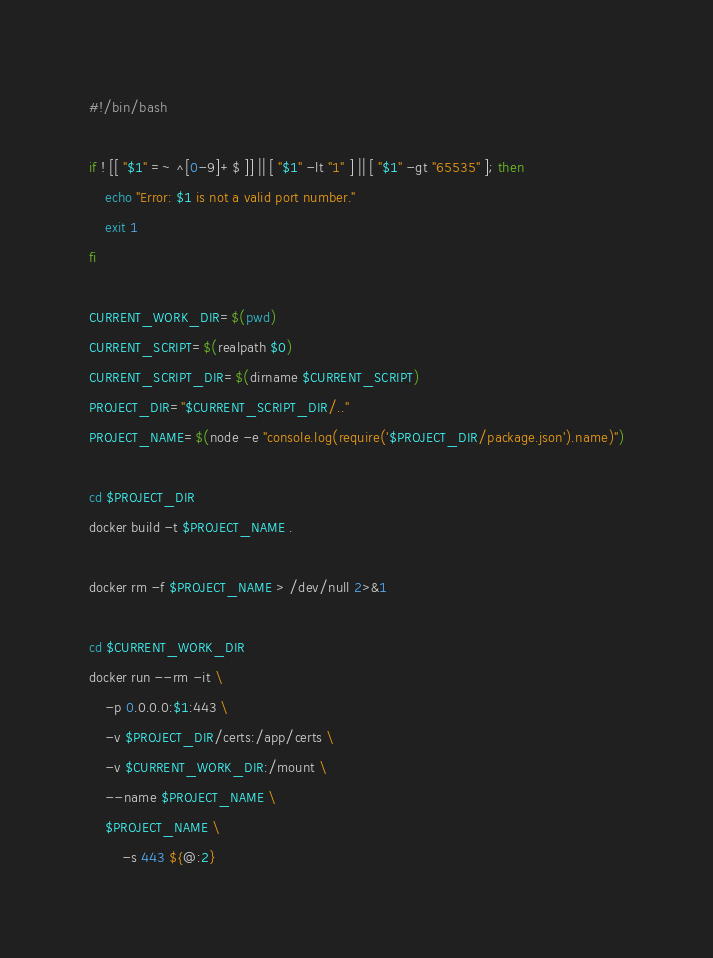Convert code to text. <code><loc_0><loc_0><loc_500><loc_500><_Bash_>#!/bin/bash

if ! [[ "$1" =~ ^[0-9]+$ ]] || [ "$1" -lt "1" ] || [ "$1" -gt "65535" ]; then
    echo "Error: $1 is not a valid port number."
    exit 1
fi

CURRENT_WORK_DIR=$(pwd)
CURRENT_SCRIPT=$(realpath $0)
CURRENT_SCRIPT_DIR=$(dirname $CURRENT_SCRIPT)
PROJECT_DIR="$CURRENT_SCRIPT_DIR/.."
PROJECT_NAME=$(node -e "console.log(require('$PROJECT_DIR/package.json').name)")

cd $PROJECT_DIR
docker build -t $PROJECT_NAME .

docker rm -f $PROJECT_NAME > /dev/null 2>&1

cd $CURRENT_WORK_DIR
docker run --rm -it \
    -p 0.0.0.0:$1:443 \
    -v $PROJECT_DIR/certs:/app/certs \
    -v $CURRENT_WORK_DIR:/mount \
    --name $PROJECT_NAME \
    $PROJECT_NAME \
        -s 443 ${@:2}</code> 